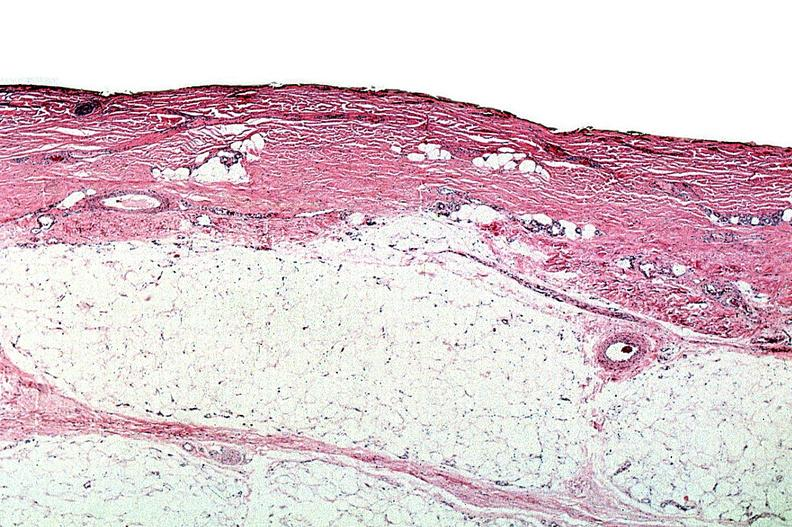where is this?
Answer the question using a single word or phrase. Skin 